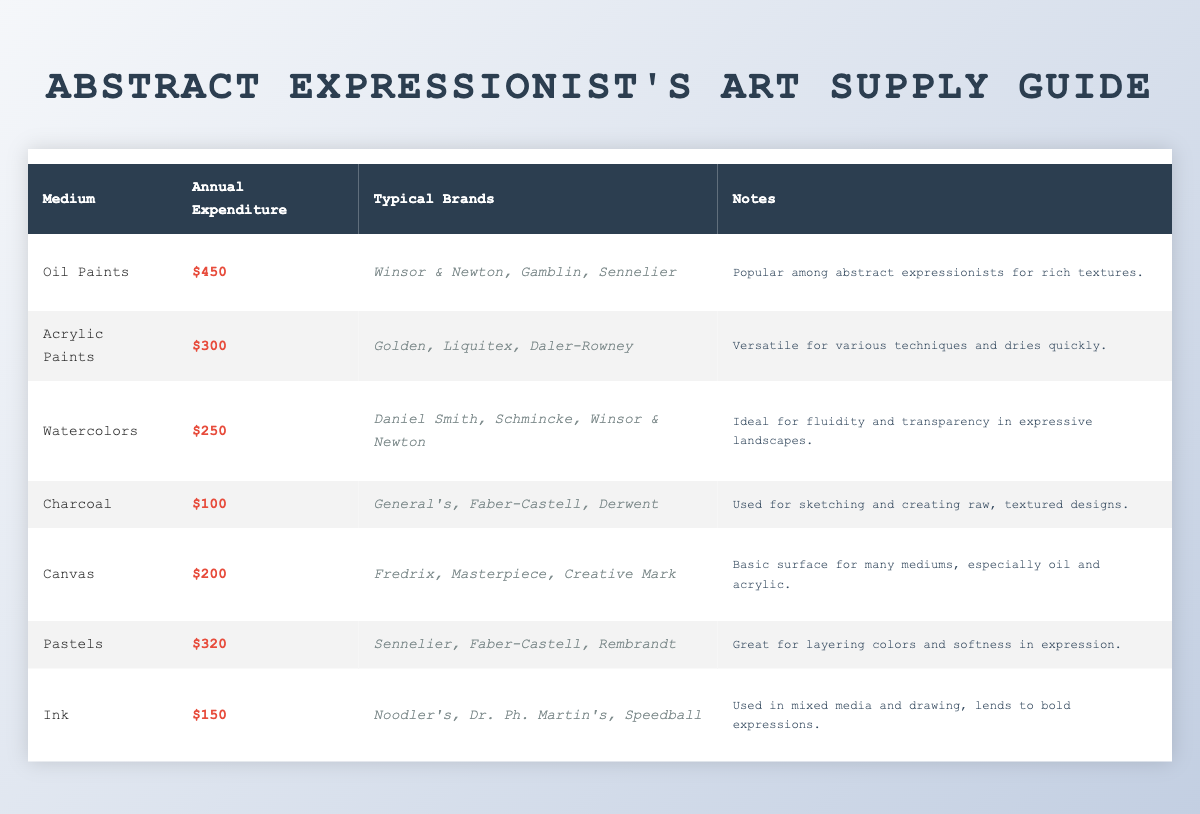What is the average annual expenditure for Oil Paints? The table shows that the average annual expenditure for Oil Paints is listed as $450, which can be found directly in the first row under the "Annual Expenditure" column.
Answer: $450 Which medium has the highest average annual expenditure? By examining all the values in the "Annual Expenditure" column, Oil Paints at $450 has the highest value, compared to other mediums such as Acrylic Paints ($300) and Pastels ($320).
Answer: Oil Paints Are typical brands for Watercolors explicitly stated in the table? The table provides a specific list of typical brands under the "Typical Brands" column for Watercolors. These brands are Daniel Smith, Schmincke, and Winsor & Newton.
Answer: Yes What is the total average annual expenditure for acrylic paints and pastels? To find the total, we sum the average expenditures for Acrylic Paints ($300) and Pastels ($320). Adding these gives us 300 + 320 = 620.
Answer: $620 Which medium has the lowest average annual expenditure, and what is that amount? The lowest expenditure in the "Annual Expenditure" column is represented by Charcoal at $100, found in the fourth row.
Answer: Charcoal, $100 If someone spends $200 on Canvas, how much more would they need to spend to reach the average expenditure for Oil Paints? The average expenditure for Oil Paints is $450. If they have already spent $200, to find out how much more is needed, we calculate 450 - 200 = 250.
Answer: $250 Is it true that Pastels are great for layering colors? The notes section for Pastels explicitly states that they are great for layering colors and softness in expression, confirming the truth of the statement.
Answer: Yes What is the average annual expenditure for all the mediums listed in the table? To calculate the average for all mediums, we first sum their expenditures: 450 (Oil) + 300 (Acrylic) + 250 (Watercolors) + 100 (Charcoal) + 200 (Canvas) + 320 (Pastels) + 150 (Ink) = 1870. Then divide by the number of mediums (7): 1870/7 = approximately 267.14.
Answer: $267.14 Do any mediums have an average annual expenditure greater than $400? From the data, only Oil Paints ($450) exceeds $400. Thus, we must confirm if other mediums like Pastels or Acrylics exceed this value, which they do not.
Answer: Yes 